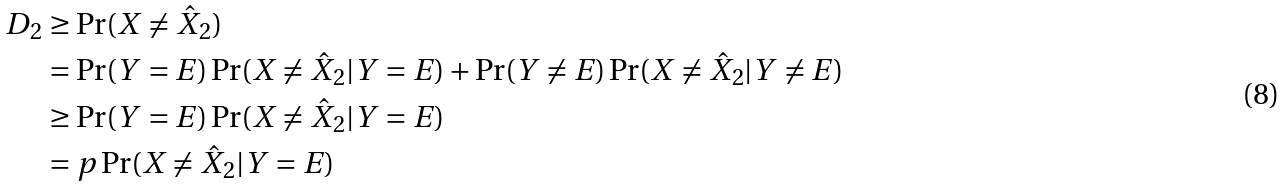Convert formula to latex. <formula><loc_0><loc_0><loc_500><loc_500>D _ { 2 } & \geq \Pr ( X \neq \hat { X } _ { 2 } ) \\ & = \Pr ( Y = E ) \Pr ( X \neq \hat { X } _ { 2 } | Y = E ) + \Pr ( Y \neq E ) \Pr ( X \neq \hat { X } _ { 2 } | Y \neq E ) \\ & \geq \Pr ( Y = E ) \Pr ( X \neq \hat { X } _ { 2 } | Y = E ) \\ & = p \Pr ( X \neq \hat { X } _ { 2 } | Y = E )</formula> 